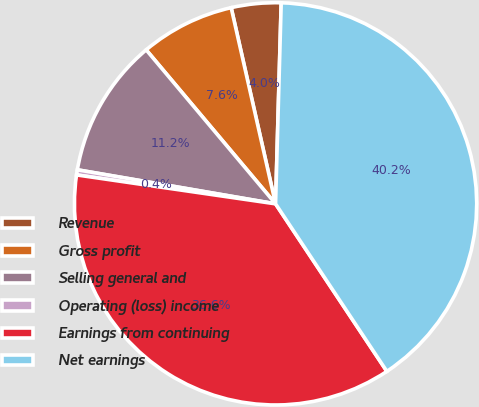<chart> <loc_0><loc_0><loc_500><loc_500><pie_chart><fcel>Revenue<fcel>Gross profit<fcel>Selling general and<fcel>Operating (loss) income<fcel>Earnings from continuing<fcel>Net earnings<nl><fcel>3.99%<fcel>7.58%<fcel>11.17%<fcel>0.41%<fcel>36.63%<fcel>40.22%<nl></chart> 